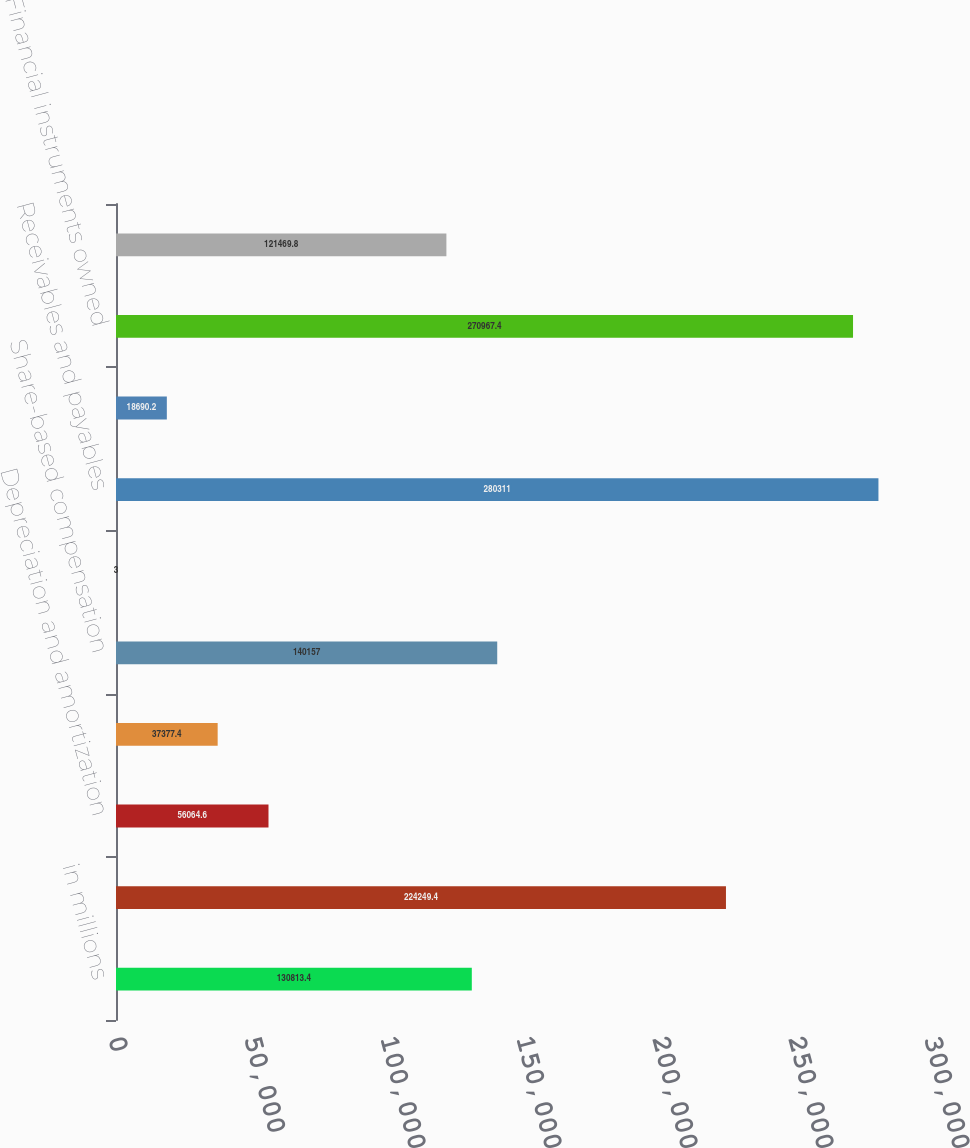<chart> <loc_0><loc_0><loc_500><loc_500><bar_chart><fcel>in millions<fcel>Net earnings<fcel>Depreciation and amortization<fcel>Deferred income taxes<fcel>Share-based compensation<fcel>Loss/(gain) related to<fcel>Receivables and payables<fcel>Collateralized transactions<fcel>Financial instruments owned<fcel>Financial instruments sold but<nl><fcel>130813<fcel>224249<fcel>56064.6<fcel>37377.4<fcel>140157<fcel>3<fcel>280311<fcel>18690.2<fcel>270967<fcel>121470<nl></chart> 